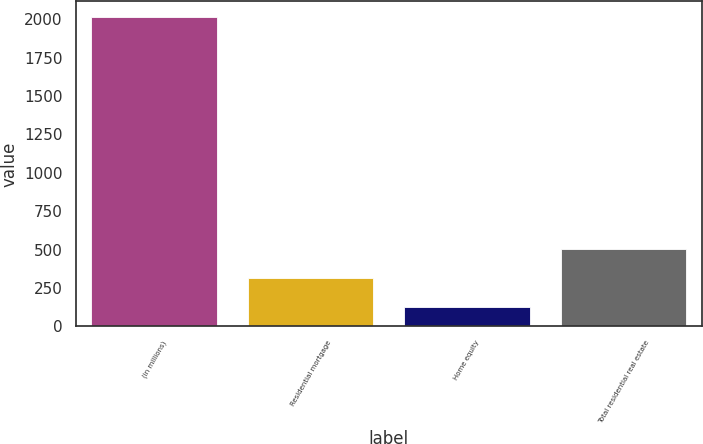Convert chart. <chart><loc_0><loc_0><loc_500><loc_500><bar_chart><fcel>(in millions)<fcel>Residential mortgage<fcel>Home equity<fcel>Total residential real estate<nl><fcel>2016<fcel>314.1<fcel>125<fcel>503.2<nl></chart> 